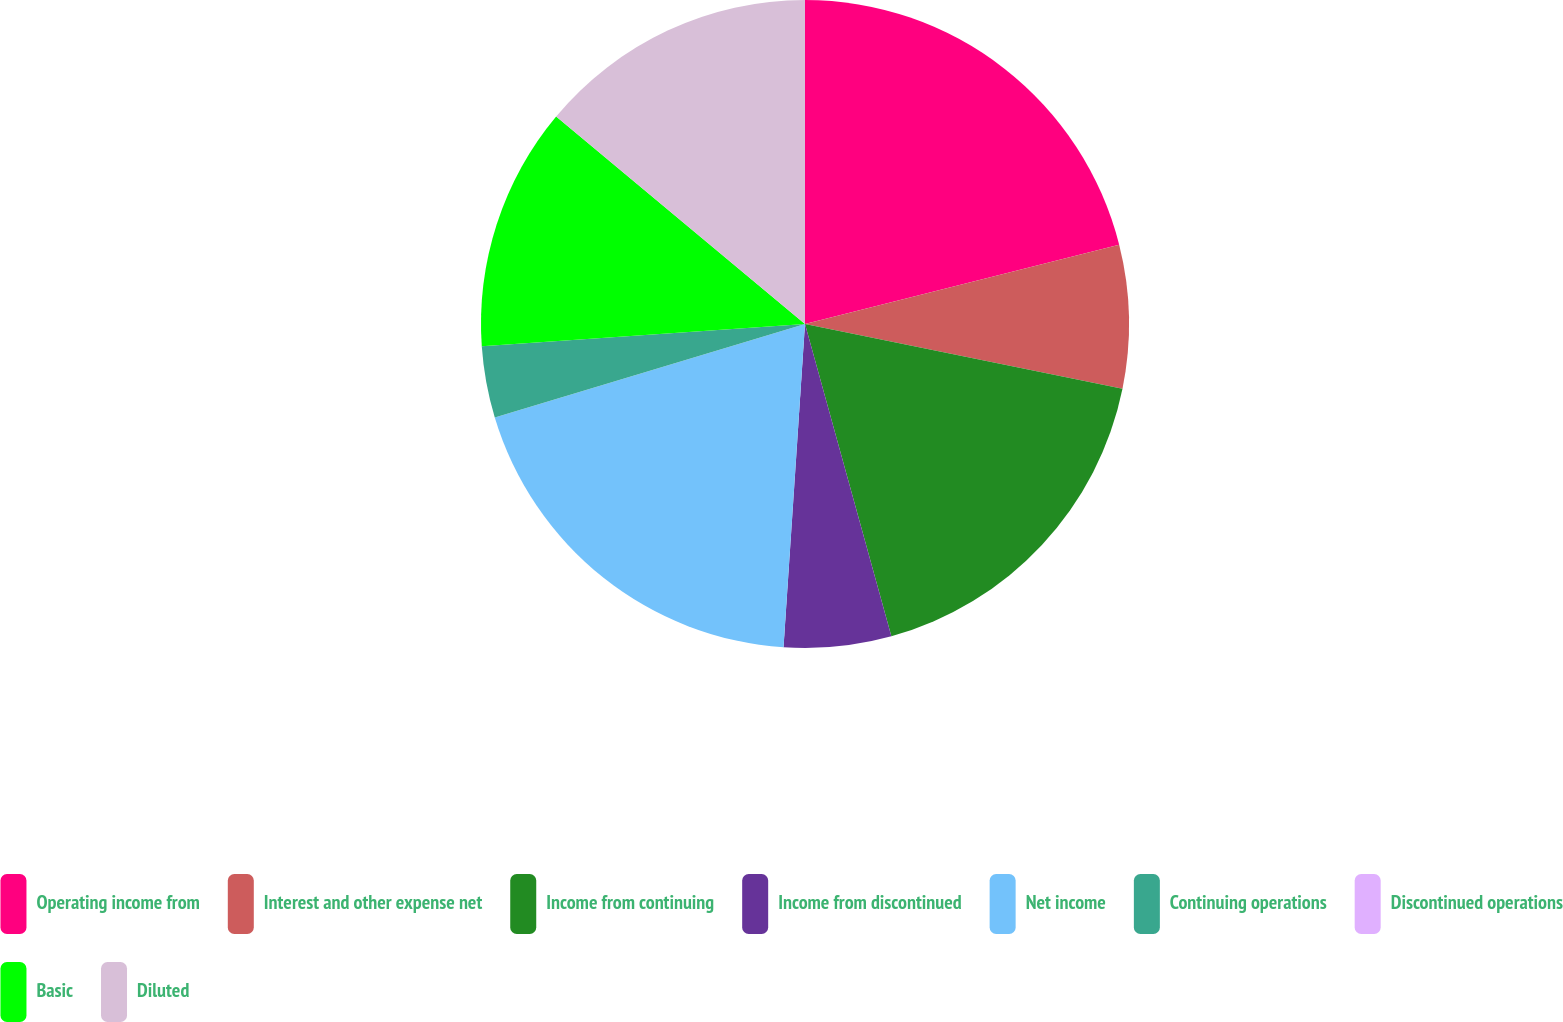<chart> <loc_0><loc_0><loc_500><loc_500><pie_chart><fcel>Operating income from<fcel>Interest and other expense net<fcel>Income from continuing<fcel>Income from discontinued<fcel>Net income<fcel>Continuing operations<fcel>Discontinued operations<fcel>Basic<fcel>Diluted<nl><fcel>21.07%<fcel>7.13%<fcel>17.51%<fcel>5.35%<fcel>19.29%<fcel>3.56%<fcel>0.0%<fcel>12.16%<fcel>13.94%<nl></chart> 